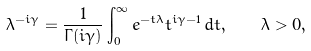Convert formula to latex. <formula><loc_0><loc_0><loc_500><loc_500>\lambda ^ { - i \gamma } = \frac { 1 } { \Gamma ( i \gamma ) } \int _ { 0 } ^ { \infty } e ^ { - t \lambda } t ^ { i \gamma - 1 } \, d t , \quad \lambda > 0 ,</formula> 